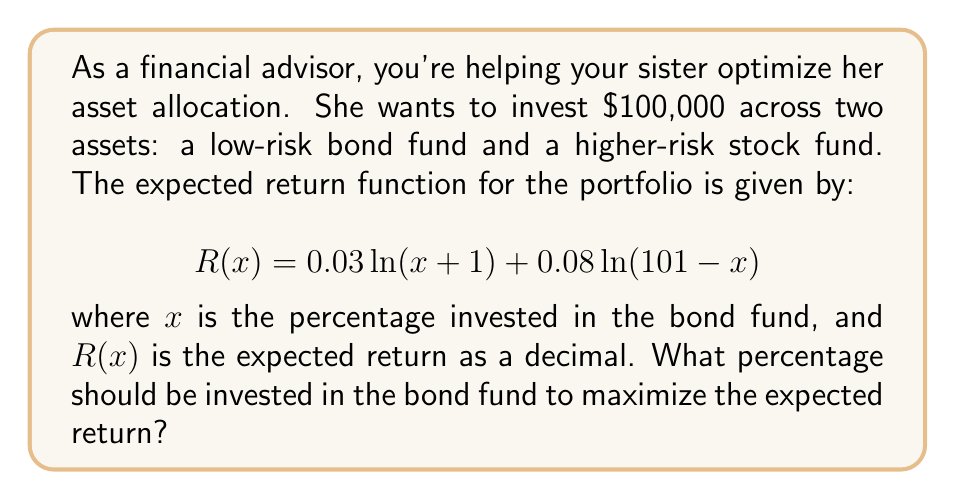Solve this math problem. To find the optimal allocation, we need to maximize the return function $R(x)$. This can be done by finding where the derivative of $R(x)$ equals zero.

Step 1: Calculate the derivative of $R(x)$
$$R'(x) = \frac{0.03}{x+1} - \frac{0.08}{101-x}$$

Step 2: Set the derivative equal to zero and solve for x
$$\frac{0.03}{x+1} - \frac{0.08}{101-x} = 0$$

Step 3: Cross-multiply
$$(0.03)(101-x) = (0.08)(x+1)$$

Step 4: Distribute
$$3.03 - 0.03x = 0.08x + 0.08$$

Step 5: Combine like terms
$$3.03 - 0.08 = 0.08x + 0.03x$$
$$2.95 = 0.11x$$

Step 6: Solve for x
$$x = \frac{2.95}{0.11} \approx 26.82$$

Therefore, to maximize the expected return, approximately 26.82% should be invested in the bond fund.
Answer: 26.82% 